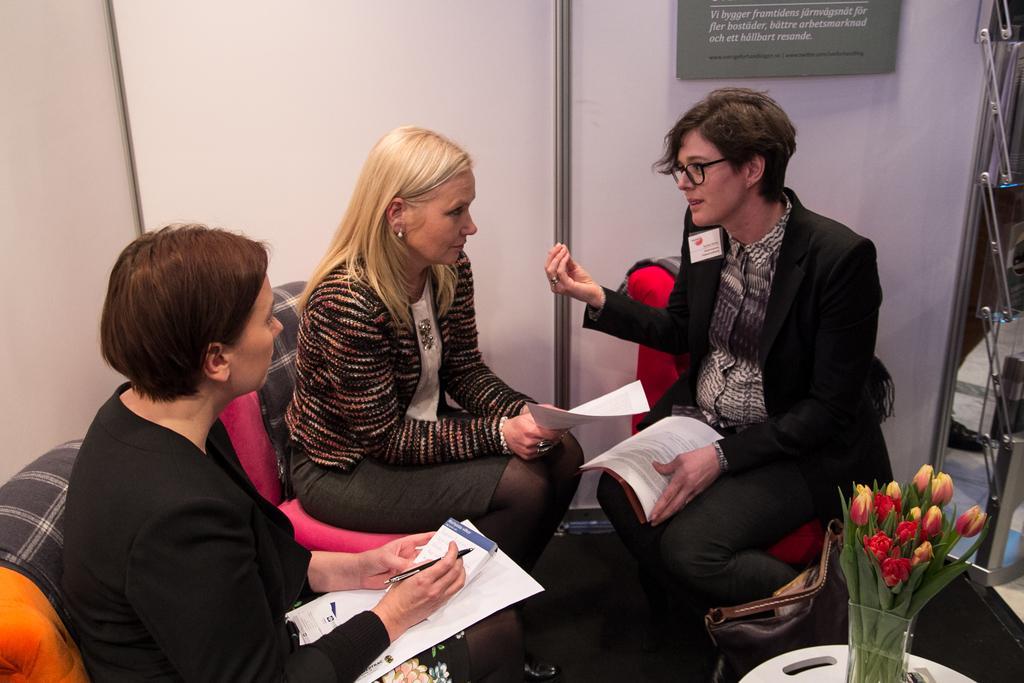Describe this image in one or two sentences. In this image I can see three women sitting on couches and holding papers in their hands. I can see a white colored table and few flowers on it which are red and yellow in color. In the background I can see the white colored surface, a grey colored board attached to it and few other objects. 